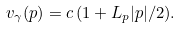Convert formula to latex. <formula><loc_0><loc_0><loc_500><loc_500>v _ { \gamma } ( p ) = c \, ( 1 + L _ { p } | p | / 2 ) .</formula> 